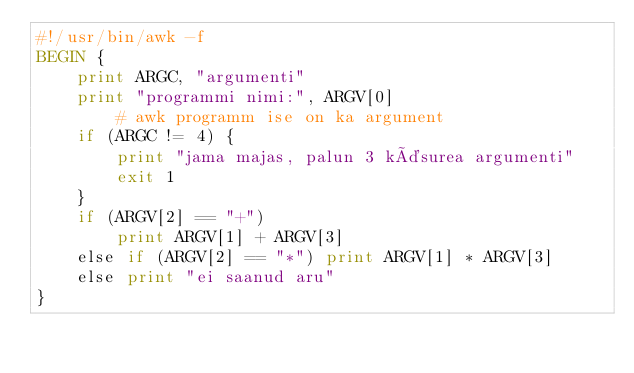<code> <loc_0><loc_0><loc_500><loc_500><_Awk_>#!/usr/bin/awk -f
BEGIN {
    print ARGC, "argumenti"
    print "programmi nimi:", ARGV[0]
        # awk programm ise on ka argument
    if (ARGC != 4) {
        print "jama majas, palun 3 käsurea argumenti"
        exit 1
    }
    if (ARGV[2] == "+")
        print ARGV[1] + ARGV[3]
    else if (ARGV[2] == "*") print ARGV[1] * ARGV[3]
    else print "ei saanud aru"
}
</code> 